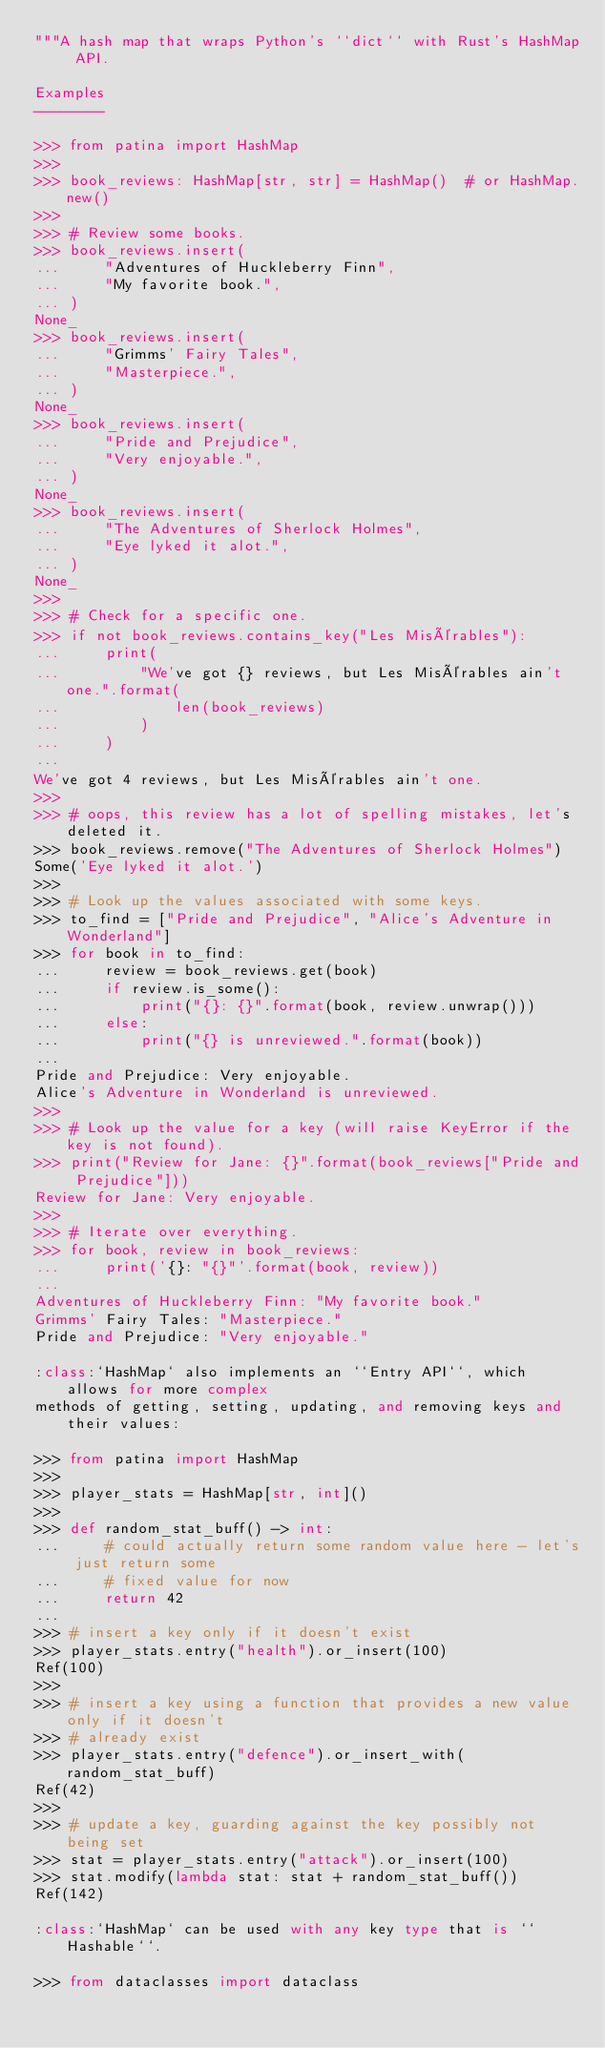<code> <loc_0><loc_0><loc_500><loc_500><_Python_>"""A hash map that wraps Python's ``dict`` with Rust's HashMap API.

Examples
--------

>>> from patina import HashMap
>>>
>>> book_reviews: HashMap[str, str] = HashMap()  # or HashMap.new()
>>>
>>> # Review some books.
>>> book_reviews.insert(
...     "Adventures of Huckleberry Finn",
...     "My favorite book.",
... )
None_
>>> book_reviews.insert(
...     "Grimms' Fairy Tales",
...     "Masterpiece.",
... )
None_
>>> book_reviews.insert(
...     "Pride and Prejudice",
...     "Very enjoyable.",
... )
None_
>>> book_reviews.insert(
...     "The Adventures of Sherlock Holmes",
...     "Eye lyked it alot.",
... )
None_
>>>
>>> # Check for a specific one.
>>> if not book_reviews.contains_key("Les Misérables"):
...     print(
...         "We've got {} reviews, but Les Misérables ain't one.".format(
...             len(book_reviews)
...         )
...     )
...
We've got 4 reviews, but Les Misérables ain't one.
>>>
>>> # oops, this review has a lot of spelling mistakes, let's deleted it.
>>> book_reviews.remove("The Adventures of Sherlock Holmes")
Some('Eye lyked it alot.')
>>>
>>> # Look up the values associated with some keys.
>>> to_find = ["Pride and Prejudice", "Alice's Adventure in Wonderland"]
>>> for book in to_find:
...     review = book_reviews.get(book)
...     if review.is_some():
...         print("{}: {}".format(book, review.unwrap()))
...     else:
...         print("{} is unreviewed.".format(book))
...
Pride and Prejudice: Very enjoyable.
Alice's Adventure in Wonderland is unreviewed.
>>>
>>> # Look up the value for a key (will raise KeyError if the key is not found).
>>> print("Review for Jane: {}".format(book_reviews["Pride and Prejudice"]))
Review for Jane: Very enjoyable.
>>>
>>> # Iterate over everything.
>>> for book, review in book_reviews:
...     print('{}: "{}"'.format(book, review))
...
Adventures of Huckleberry Finn: "My favorite book."
Grimms' Fairy Tales: "Masterpiece."
Pride and Prejudice: "Very enjoyable."

:class:`HashMap` also implements an ``Entry API``, which allows for more complex
methods of getting, setting, updating, and removing keys and their values:

>>> from patina import HashMap
>>>
>>> player_stats = HashMap[str, int]()
>>>
>>> def random_stat_buff() -> int:
...     # could actually return some random value here - let's just return some
...     # fixed value for now
...     return 42
...
>>> # insert a key only if it doesn't exist
>>> player_stats.entry("health").or_insert(100)
Ref(100)
>>>
>>> # insert a key using a function that provides a new value only if it doesn't
>>> # already exist
>>> player_stats.entry("defence").or_insert_with(random_stat_buff)
Ref(42)
>>>
>>> # update a key, guarding against the key possibly not being set
>>> stat = player_stats.entry("attack").or_insert(100)
>>> stat.modify(lambda stat: stat + random_stat_buff())
Ref(142)

:class:`HashMap` can be used with any key type that is ``Hashable``.

>>> from dataclasses import dataclass</code> 